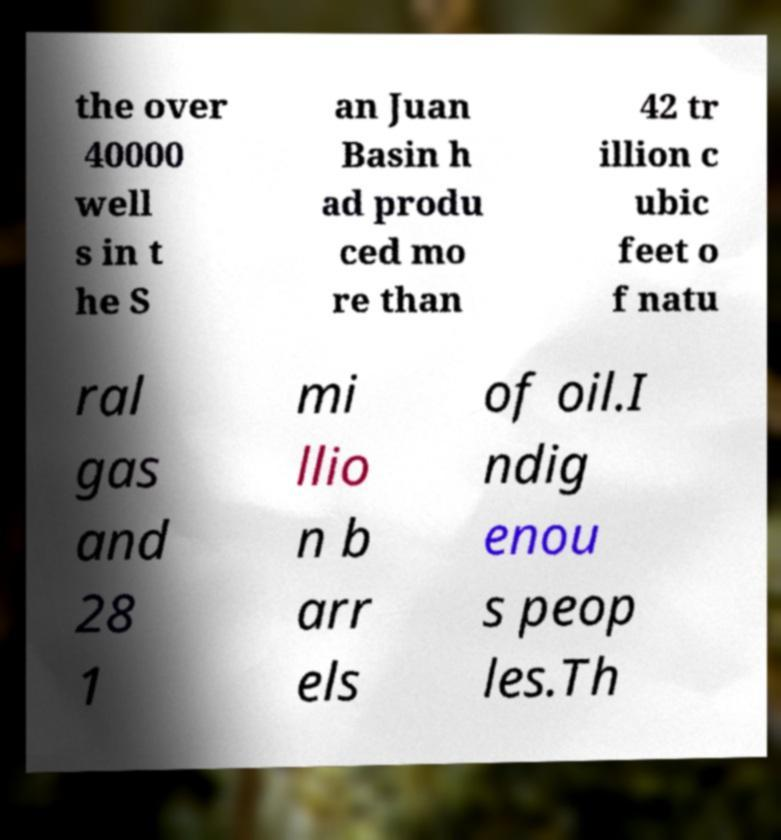For documentation purposes, I need the text within this image transcribed. Could you provide that? the over 40000 well s in t he S an Juan Basin h ad produ ced mo re than 42 tr illion c ubic feet o f natu ral gas and 28 1 mi llio n b arr els of oil.I ndig enou s peop les.Th 